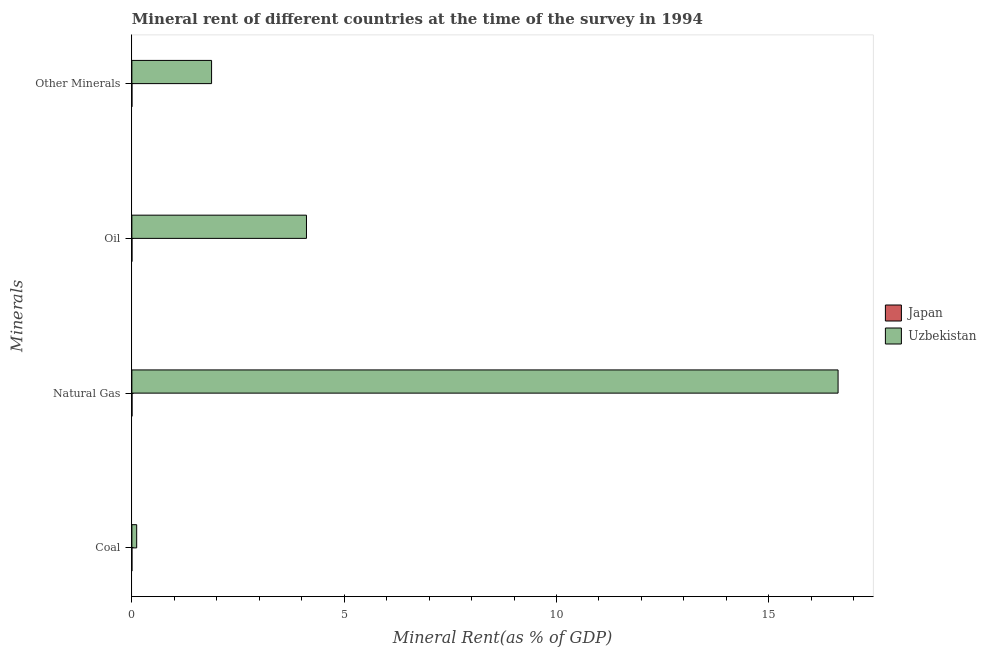Are the number of bars per tick equal to the number of legend labels?
Provide a short and direct response. Yes. How many bars are there on the 2nd tick from the top?
Keep it short and to the point. 2. How many bars are there on the 3rd tick from the bottom?
Give a very brief answer. 2. What is the label of the 3rd group of bars from the top?
Your answer should be compact. Natural Gas. What is the oil rent in Japan?
Offer a very short reply. 0. Across all countries, what is the maximum natural gas rent?
Give a very brief answer. 16.63. Across all countries, what is the minimum oil rent?
Ensure brevity in your answer.  0. In which country was the oil rent maximum?
Give a very brief answer. Uzbekistan. What is the total  rent of other minerals in the graph?
Offer a terse response. 1.88. What is the difference between the natural gas rent in Japan and that in Uzbekistan?
Your answer should be compact. -16.63. What is the difference between the coal rent in Japan and the  rent of other minerals in Uzbekistan?
Offer a very short reply. -1.88. What is the average coal rent per country?
Your answer should be very brief. 0.06. What is the difference between the coal rent and natural gas rent in Uzbekistan?
Give a very brief answer. -16.52. What is the ratio of the oil rent in Uzbekistan to that in Japan?
Give a very brief answer. 3960.71. What is the difference between the highest and the second highest coal rent?
Ensure brevity in your answer.  0.11. What is the difference between the highest and the lowest coal rent?
Ensure brevity in your answer.  0.11. In how many countries, is the natural gas rent greater than the average natural gas rent taken over all countries?
Offer a very short reply. 1. Is it the case that in every country, the sum of the natural gas rent and coal rent is greater than the sum of  rent of other minerals and oil rent?
Your response must be concise. No. What does the 1st bar from the top in Coal represents?
Your response must be concise. Uzbekistan. What does the 2nd bar from the bottom in Oil represents?
Offer a terse response. Uzbekistan. Is it the case that in every country, the sum of the coal rent and natural gas rent is greater than the oil rent?
Your response must be concise. Yes. How many bars are there?
Give a very brief answer. 8. How many countries are there in the graph?
Keep it short and to the point. 2. Are the values on the major ticks of X-axis written in scientific E-notation?
Give a very brief answer. No. How many legend labels are there?
Ensure brevity in your answer.  2. How are the legend labels stacked?
Provide a short and direct response. Vertical. What is the title of the graph?
Offer a terse response. Mineral rent of different countries at the time of the survey in 1994. What is the label or title of the X-axis?
Your response must be concise. Mineral Rent(as % of GDP). What is the label or title of the Y-axis?
Provide a succinct answer. Minerals. What is the Mineral Rent(as % of GDP) of Japan in Coal?
Ensure brevity in your answer.  3.62869321077954e-7. What is the Mineral Rent(as % of GDP) of Uzbekistan in Coal?
Ensure brevity in your answer.  0.11. What is the Mineral Rent(as % of GDP) in Japan in Natural Gas?
Ensure brevity in your answer.  0. What is the Mineral Rent(as % of GDP) in Uzbekistan in Natural Gas?
Give a very brief answer. 16.63. What is the Mineral Rent(as % of GDP) in Japan in Oil?
Your response must be concise. 0. What is the Mineral Rent(as % of GDP) in Uzbekistan in Oil?
Keep it short and to the point. 4.11. What is the Mineral Rent(as % of GDP) in Japan in Other Minerals?
Your answer should be very brief. 0. What is the Mineral Rent(as % of GDP) in Uzbekistan in Other Minerals?
Your answer should be very brief. 1.88. Across all Minerals, what is the maximum Mineral Rent(as % of GDP) of Japan?
Make the answer very short. 0. Across all Minerals, what is the maximum Mineral Rent(as % of GDP) of Uzbekistan?
Offer a terse response. 16.63. Across all Minerals, what is the minimum Mineral Rent(as % of GDP) in Japan?
Make the answer very short. 3.62869321077954e-7. Across all Minerals, what is the minimum Mineral Rent(as % of GDP) of Uzbekistan?
Your response must be concise. 0.11. What is the total Mineral Rent(as % of GDP) of Japan in the graph?
Your answer should be very brief. 0. What is the total Mineral Rent(as % of GDP) in Uzbekistan in the graph?
Keep it short and to the point. 22.73. What is the difference between the Mineral Rent(as % of GDP) in Japan in Coal and that in Natural Gas?
Provide a succinct answer. -0. What is the difference between the Mineral Rent(as % of GDP) in Uzbekistan in Coal and that in Natural Gas?
Your answer should be compact. -16.52. What is the difference between the Mineral Rent(as % of GDP) of Japan in Coal and that in Oil?
Keep it short and to the point. -0. What is the difference between the Mineral Rent(as % of GDP) of Uzbekistan in Coal and that in Oil?
Your answer should be very brief. -4. What is the difference between the Mineral Rent(as % of GDP) in Japan in Coal and that in Other Minerals?
Offer a terse response. -0. What is the difference between the Mineral Rent(as % of GDP) in Uzbekistan in Coal and that in Other Minerals?
Your response must be concise. -1.76. What is the difference between the Mineral Rent(as % of GDP) in Japan in Natural Gas and that in Oil?
Your answer should be compact. 0. What is the difference between the Mineral Rent(as % of GDP) in Uzbekistan in Natural Gas and that in Oil?
Provide a short and direct response. 12.52. What is the difference between the Mineral Rent(as % of GDP) of Japan in Natural Gas and that in Other Minerals?
Make the answer very short. 0. What is the difference between the Mineral Rent(as % of GDP) in Uzbekistan in Natural Gas and that in Other Minerals?
Give a very brief answer. 14.76. What is the difference between the Mineral Rent(as % of GDP) of Uzbekistan in Oil and that in Other Minerals?
Ensure brevity in your answer.  2.23. What is the difference between the Mineral Rent(as % of GDP) of Japan in Coal and the Mineral Rent(as % of GDP) of Uzbekistan in Natural Gas?
Your response must be concise. -16.63. What is the difference between the Mineral Rent(as % of GDP) in Japan in Coal and the Mineral Rent(as % of GDP) in Uzbekistan in Oil?
Your answer should be very brief. -4.11. What is the difference between the Mineral Rent(as % of GDP) in Japan in Coal and the Mineral Rent(as % of GDP) in Uzbekistan in Other Minerals?
Offer a terse response. -1.88. What is the difference between the Mineral Rent(as % of GDP) of Japan in Natural Gas and the Mineral Rent(as % of GDP) of Uzbekistan in Oil?
Provide a short and direct response. -4.11. What is the difference between the Mineral Rent(as % of GDP) in Japan in Natural Gas and the Mineral Rent(as % of GDP) in Uzbekistan in Other Minerals?
Offer a very short reply. -1.87. What is the difference between the Mineral Rent(as % of GDP) in Japan in Oil and the Mineral Rent(as % of GDP) in Uzbekistan in Other Minerals?
Your answer should be compact. -1.88. What is the average Mineral Rent(as % of GDP) of Japan per Minerals?
Provide a short and direct response. 0. What is the average Mineral Rent(as % of GDP) of Uzbekistan per Minerals?
Make the answer very short. 5.68. What is the difference between the Mineral Rent(as % of GDP) in Japan and Mineral Rent(as % of GDP) in Uzbekistan in Coal?
Offer a terse response. -0.11. What is the difference between the Mineral Rent(as % of GDP) of Japan and Mineral Rent(as % of GDP) of Uzbekistan in Natural Gas?
Provide a succinct answer. -16.63. What is the difference between the Mineral Rent(as % of GDP) of Japan and Mineral Rent(as % of GDP) of Uzbekistan in Oil?
Give a very brief answer. -4.11. What is the difference between the Mineral Rent(as % of GDP) in Japan and Mineral Rent(as % of GDP) in Uzbekistan in Other Minerals?
Keep it short and to the point. -1.88. What is the ratio of the Mineral Rent(as % of GDP) in Uzbekistan in Coal to that in Natural Gas?
Your answer should be compact. 0.01. What is the ratio of the Mineral Rent(as % of GDP) of Japan in Coal to that in Oil?
Make the answer very short. 0. What is the ratio of the Mineral Rent(as % of GDP) of Uzbekistan in Coal to that in Oil?
Your answer should be compact. 0.03. What is the ratio of the Mineral Rent(as % of GDP) in Japan in Coal to that in Other Minerals?
Keep it short and to the point. 0. What is the ratio of the Mineral Rent(as % of GDP) in Uzbekistan in Coal to that in Other Minerals?
Offer a very short reply. 0.06. What is the ratio of the Mineral Rent(as % of GDP) of Japan in Natural Gas to that in Oil?
Provide a succinct answer. 2.95. What is the ratio of the Mineral Rent(as % of GDP) in Uzbekistan in Natural Gas to that in Oil?
Provide a succinct answer. 4.04. What is the ratio of the Mineral Rent(as % of GDP) of Japan in Natural Gas to that in Other Minerals?
Keep it short and to the point. 5.76. What is the ratio of the Mineral Rent(as % of GDP) in Uzbekistan in Natural Gas to that in Other Minerals?
Your answer should be compact. 8.86. What is the ratio of the Mineral Rent(as % of GDP) in Japan in Oil to that in Other Minerals?
Provide a short and direct response. 1.95. What is the ratio of the Mineral Rent(as % of GDP) of Uzbekistan in Oil to that in Other Minerals?
Provide a succinct answer. 2.19. What is the difference between the highest and the second highest Mineral Rent(as % of GDP) in Japan?
Your answer should be very brief. 0. What is the difference between the highest and the second highest Mineral Rent(as % of GDP) of Uzbekistan?
Your answer should be compact. 12.52. What is the difference between the highest and the lowest Mineral Rent(as % of GDP) in Japan?
Your response must be concise. 0. What is the difference between the highest and the lowest Mineral Rent(as % of GDP) in Uzbekistan?
Give a very brief answer. 16.52. 